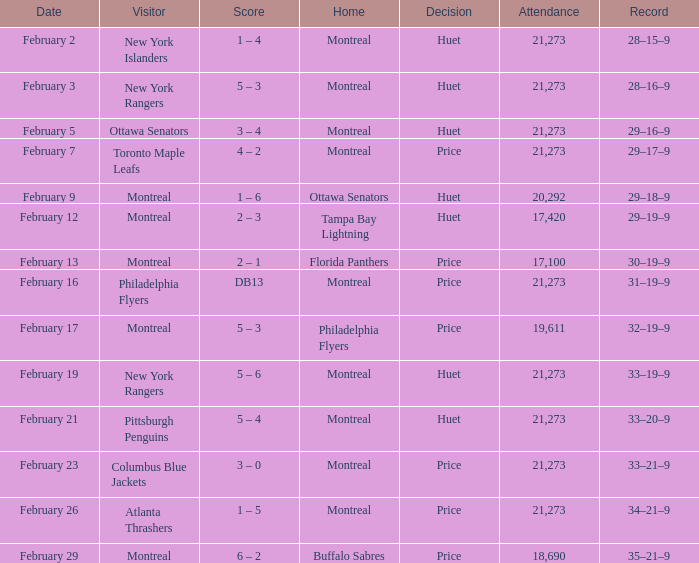What was the date of the game when the Canadiens had a record of 31–19–9? February 16. 